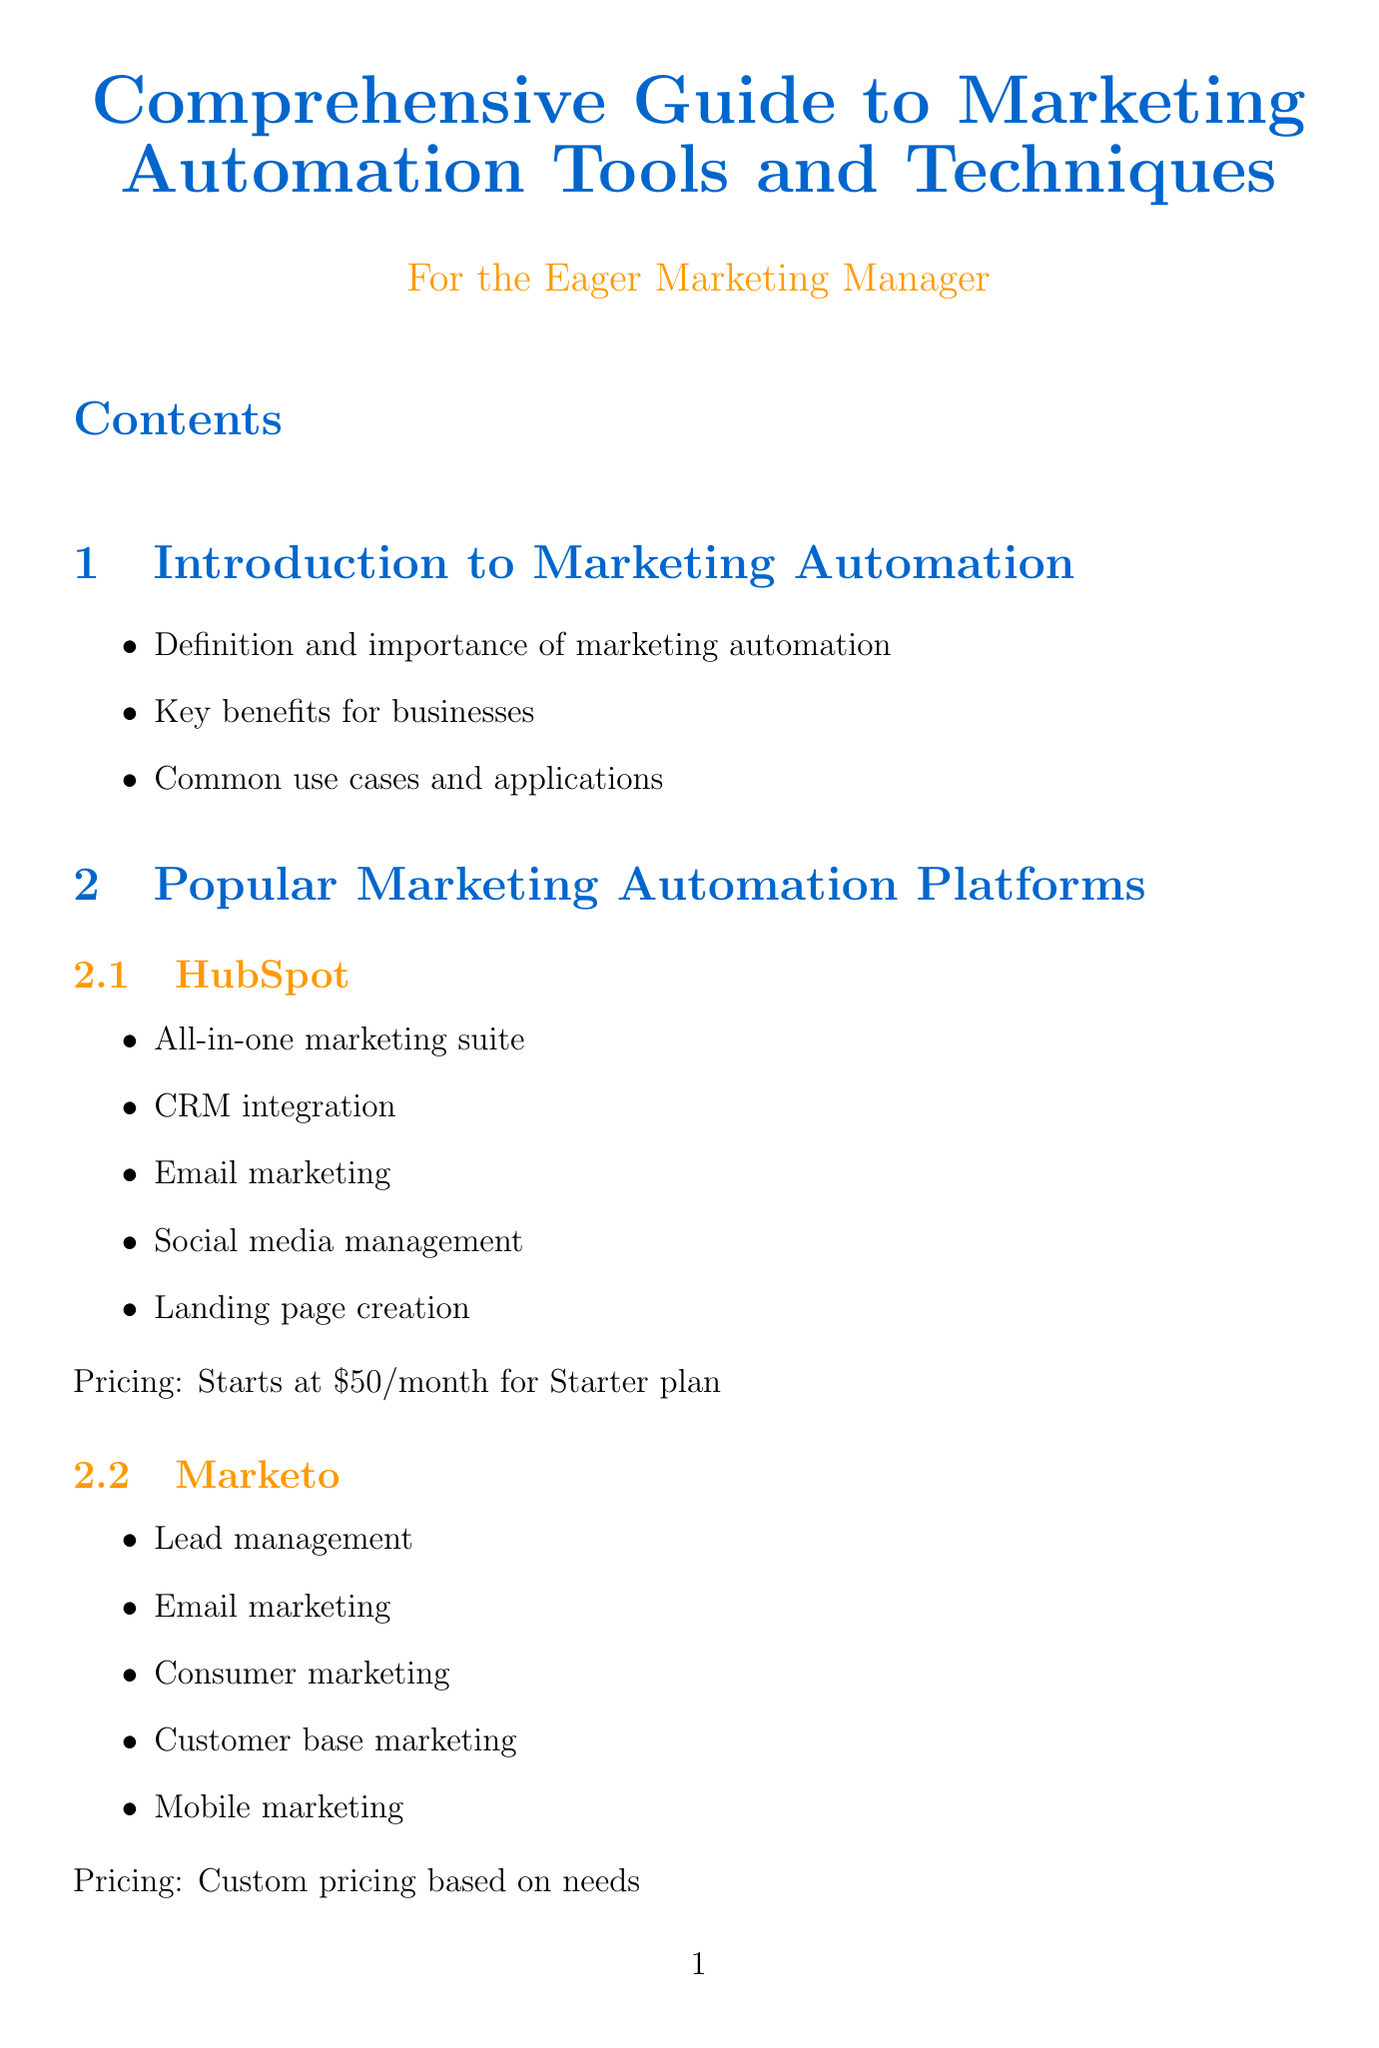what is the title of the document? The title of the document is provided at the beginning of the document.
Answer: Comprehensive Guide to Marketing Automation Tools and Techniques how many marketing automation platforms are listed? The number of platforms is specified in the Popular Marketing Automation Platforms chapter.
Answer: Four what is the starting price for Mailchimp? The pricing information for Mailchimp is detailed in the Popular Marketing Automation Platforms section.
Answer: Starts at eleven dollars per month for Essentials plan what technique involves sending targeted content over time? The specific technique is described in the Essential Marketing Automation Techniques section.
Answer: Drip Campaigns which company implemented Marketo for lead scoring and nurturing? The case studies provide the names of companies and their implemented solutions.
Answer: Adobe what is the benefit of lead scoring? The benefits of lead scoring are listed in the description of the technique in the document.
Answer: Prioritize high-quality leads how does Salesforce CRM benefit marketing integration? The integration benefits for Salesforce CRM are outlined under Integration with Other Marketing Tools.
Answer: Align marketing and sales efforts what is one future trend in marketing automation? Trends are listed in the Future Trends in Marketing Automation section.
Answer: Artificial Intelligence and Machine Learning 